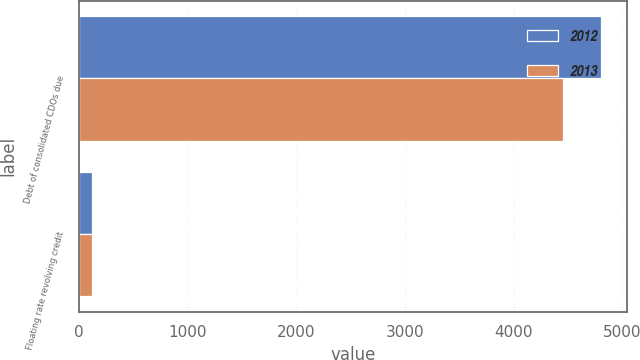<chart> <loc_0><loc_0><loc_500><loc_500><stacked_bar_chart><ecel><fcel>Debt of consolidated CDOs due<fcel>Floating rate revolving credit<nl><fcel>2012<fcel>4804<fcel>120<nl><fcel>2013<fcel>4450<fcel>118<nl></chart> 